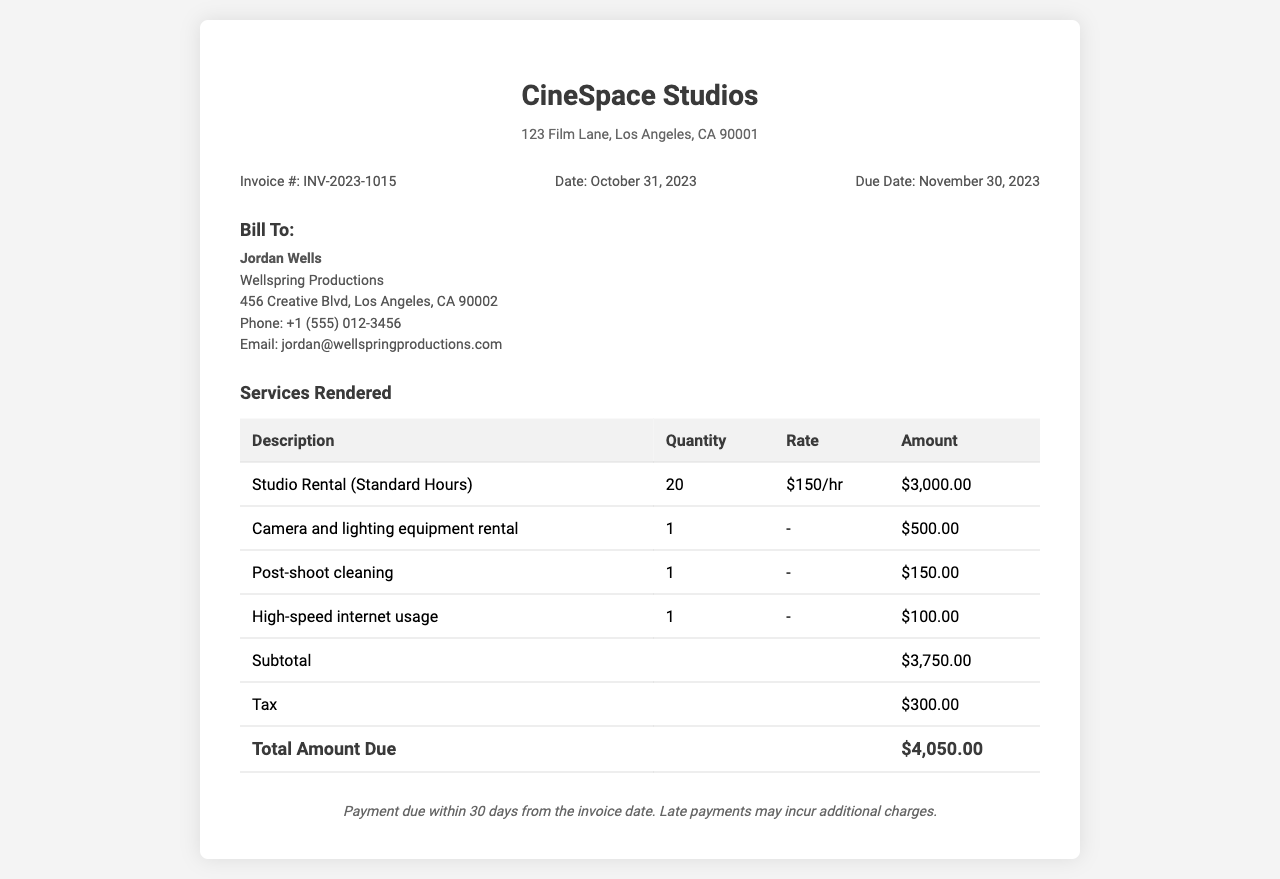What is the invoice number? The invoice number is listed in the document's invoice details section as INV-2023-1015.
Answer: INV-2023-1015 What is the invoice date? The invoice date is stated in the document, indicating when the invoice was issued, which is October 31, 2023.
Answer: October 31, 2023 Who is the billed entity? The billed entity is specified in the billing info section, showing the name of the person or organization being charged, which is Jordan Wells.
Answer: Jordan Wells What is the hourly rate for studio rental? The hourly rate for studio rental is provided in the services rendered table, explicitly stated as $150 per hour.
Answer: $150/hr How many hours of studio rental are billed? The number of hours billed for studio rental appears in the services rendered table, indicating a total of 20 hours.
Answer: 20 What is the subtotal before tax? The subtotal before tax is given in the services rendered table, which summarizes the charges and amounts to $3,750.00.
Answer: $3,750.00 What is the total amount due? The total amount due is calculated as reflected at the bottom of the services rendered table, indicating the total charge including tax, which is $4,050.00.
Answer: $4,050.00 What is the due date for payment? The due date for payment is mentioned in the invoice details section, indicating when the payment needs to be completed, which is November 30, 2023.
Answer: November 30, 2023 What is the charge for post-shoot cleaning? The charge for post-shoot cleaning is listed in the services rendered table, where it is indicated as $150.00.
Answer: $150.00 